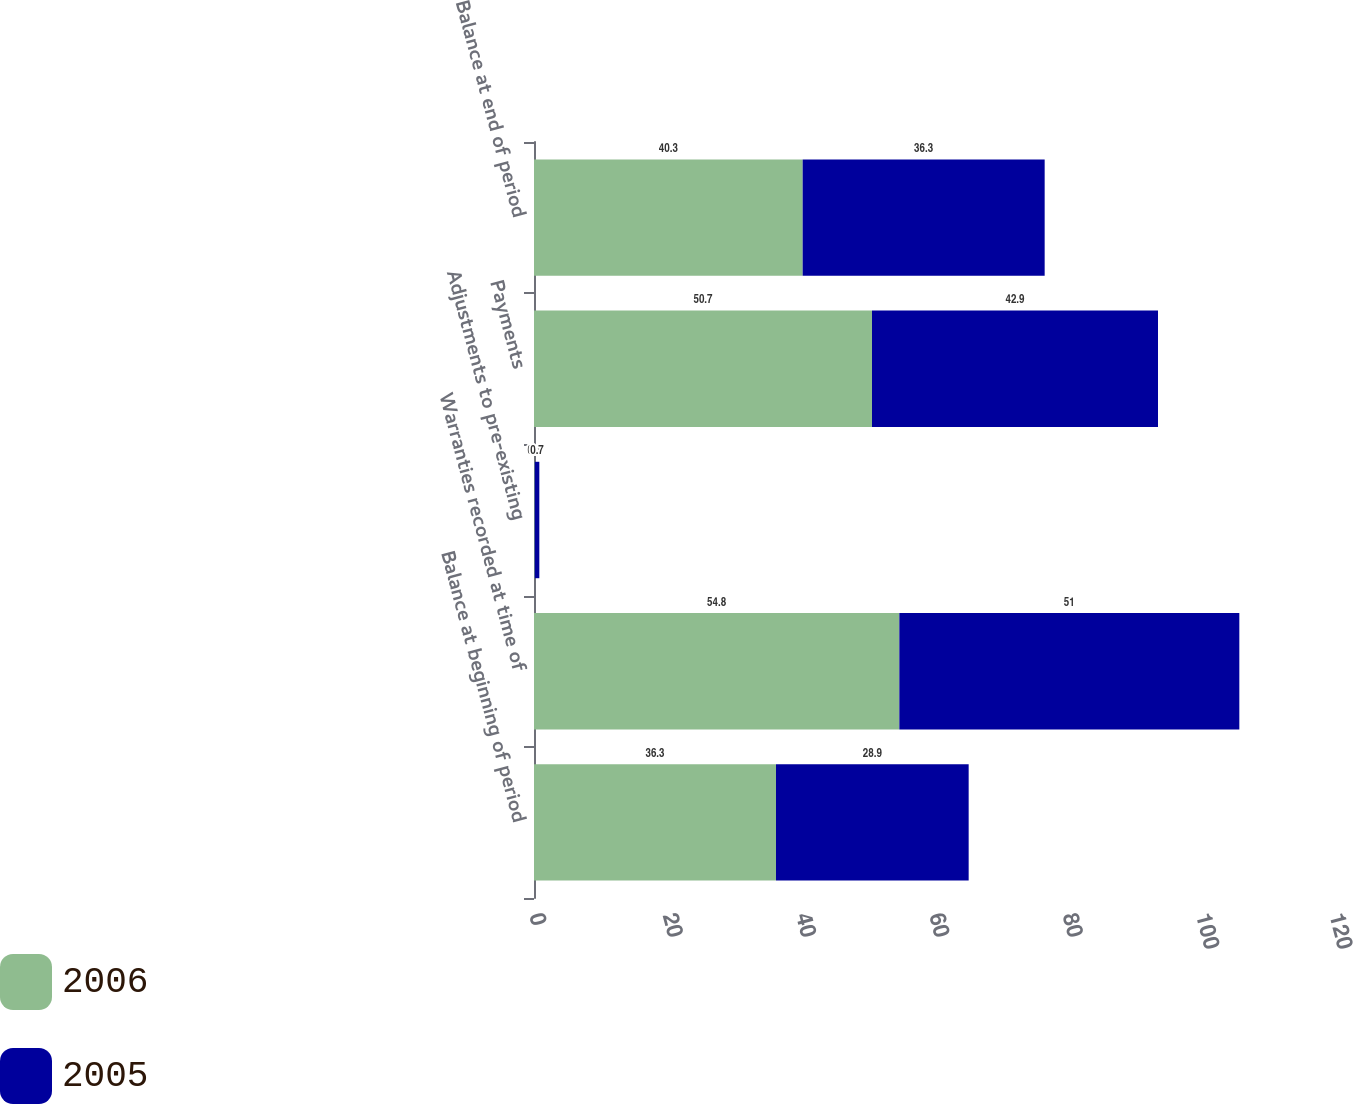Convert chart to OTSL. <chart><loc_0><loc_0><loc_500><loc_500><stacked_bar_chart><ecel><fcel>Balance at beginning of period<fcel>Warranties recorded at time of<fcel>Adjustments to pre-existing<fcel>Payments<fcel>Balance at end of period<nl><fcel>2006<fcel>36.3<fcel>54.8<fcel>0.1<fcel>50.7<fcel>40.3<nl><fcel>2005<fcel>28.9<fcel>51<fcel>0.7<fcel>42.9<fcel>36.3<nl></chart> 